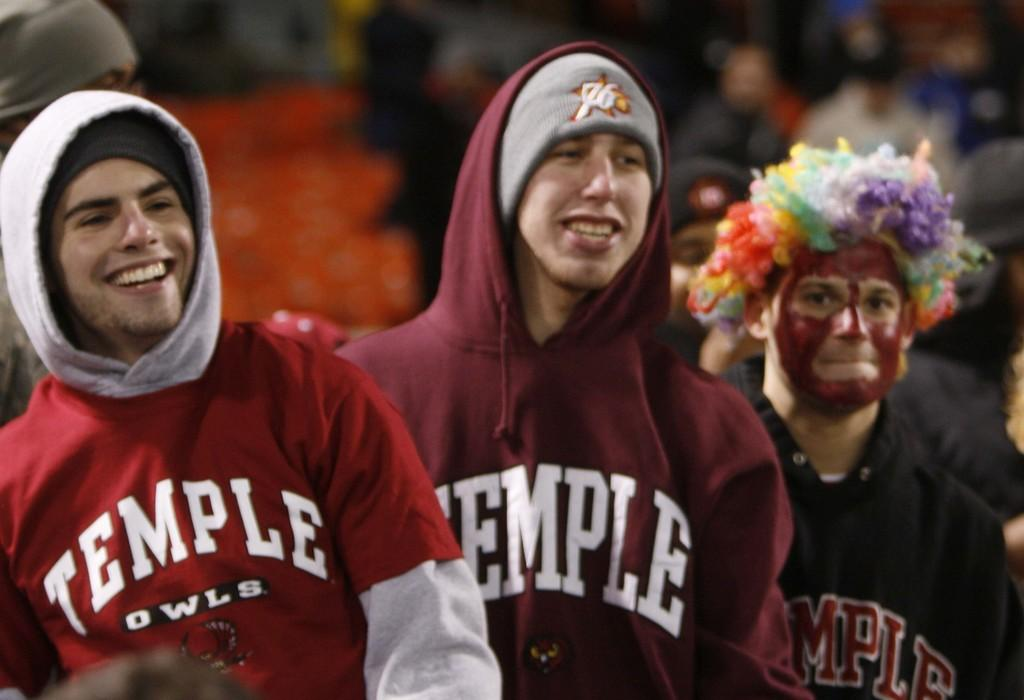<image>
Present a compact description of the photo's key features. Fans that have maroon sweatshirt on with TEMPLE in white letters. 